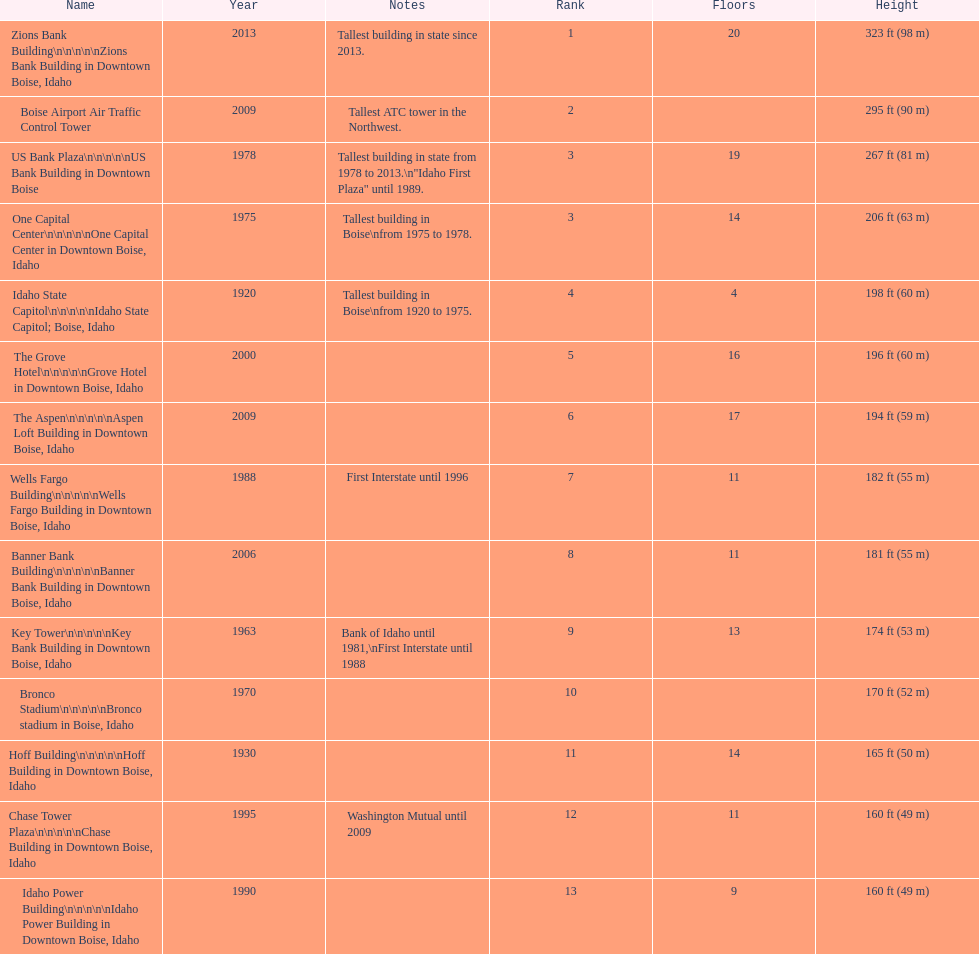What is the number of floors of the oldest building? 4. 